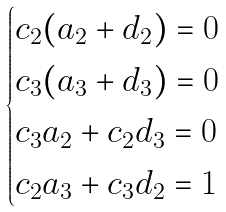Convert formula to latex. <formula><loc_0><loc_0><loc_500><loc_500>\begin{cases} c _ { 2 } ( a _ { 2 } + d _ { 2 } ) = 0 \\ c _ { 3 } ( a _ { 3 } + d _ { 3 } ) = 0 \\ c _ { 3 } a _ { 2 } + c _ { 2 } d _ { 3 } = 0 \\ c _ { 2 } a _ { 3 } + c _ { 3 } d _ { 2 } = 1 \\ \end{cases}</formula> 